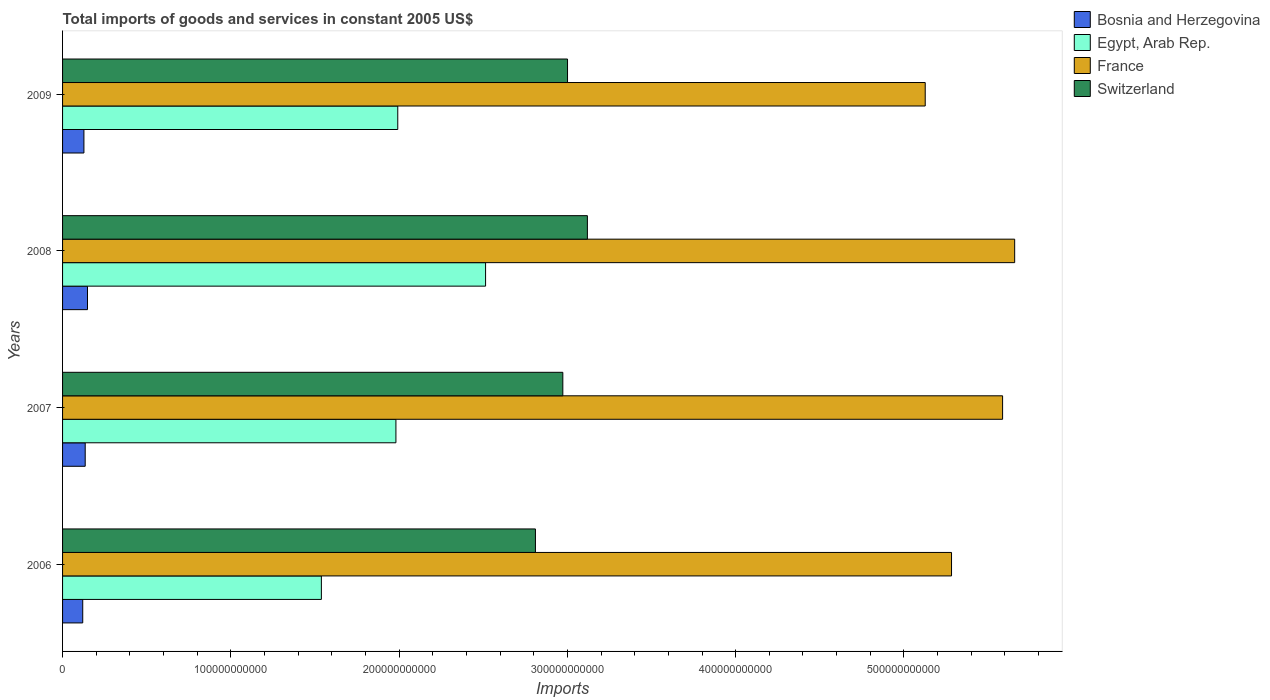How many groups of bars are there?
Offer a terse response. 4. Are the number of bars on each tick of the Y-axis equal?
Offer a very short reply. Yes. How many bars are there on the 2nd tick from the top?
Offer a terse response. 4. What is the label of the 3rd group of bars from the top?
Offer a terse response. 2007. What is the total imports of goods and services in Bosnia and Herzegovina in 2007?
Provide a short and direct response. 1.35e+1. Across all years, what is the maximum total imports of goods and services in France?
Offer a terse response. 5.66e+11. Across all years, what is the minimum total imports of goods and services in Egypt, Arab Rep.?
Give a very brief answer. 1.54e+11. In which year was the total imports of goods and services in Bosnia and Herzegovina maximum?
Provide a short and direct response. 2008. In which year was the total imports of goods and services in Switzerland minimum?
Your answer should be very brief. 2006. What is the total total imports of goods and services in France in the graph?
Keep it short and to the point. 2.17e+12. What is the difference between the total imports of goods and services in Egypt, Arab Rep. in 2006 and that in 2008?
Offer a terse response. -9.76e+1. What is the difference between the total imports of goods and services in Switzerland in 2009 and the total imports of goods and services in France in 2008?
Provide a succinct answer. -2.66e+11. What is the average total imports of goods and services in France per year?
Provide a short and direct response. 5.41e+11. In the year 2008, what is the difference between the total imports of goods and services in Bosnia and Herzegovina and total imports of goods and services in Egypt, Arab Rep.?
Make the answer very short. -2.37e+11. In how many years, is the total imports of goods and services in Egypt, Arab Rep. greater than 560000000000 US$?
Ensure brevity in your answer.  0. What is the ratio of the total imports of goods and services in Switzerland in 2006 to that in 2008?
Keep it short and to the point. 0.9. Is the total imports of goods and services in France in 2006 less than that in 2009?
Your answer should be compact. No. Is the difference between the total imports of goods and services in Bosnia and Herzegovina in 2008 and 2009 greater than the difference between the total imports of goods and services in Egypt, Arab Rep. in 2008 and 2009?
Give a very brief answer. No. What is the difference between the highest and the second highest total imports of goods and services in Egypt, Arab Rep.?
Your answer should be very brief. 5.22e+1. What is the difference between the highest and the lowest total imports of goods and services in France?
Make the answer very short. 5.32e+1. Is the sum of the total imports of goods and services in France in 2006 and 2007 greater than the maximum total imports of goods and services in Switzerland across all years?
Your answer should be very brief. Yes. What does the 2nd bar from the top in 2006 represents?
Your answer should be very brief. France. What does the 2nd bar from the bottom in 2009 represents?
Offer a very short reply. Egypt, Arab Rep. How many years are there in the graph?
Your answer should be compact. 4. What is the difference between two consecutive major ticks on the X-axis?
Offer a terse response. 1.00e+11. Are the values on the major ticks of X-axis written in scientific E-notation?
Provide a short and direct response. No. Does the graph contain any zero values?
Offer a very short reply. No. Where does the legend appear in the graph?
Keep it short and to the point. Top right. How many legend labels are there?
Your response must be concise. 4. How are the legend labels stacked?
Your answer should be compact. Vertical. What is the title of the graph?
Offer a terse response. Total imports of goods and services in constant 2005 US$. Does "Haiti" appear as one of the legend labels in the graph?
Give a very brief answer. No. What is the label or title of the X-axis?
Provide a succinct answer. Imports. What is the Imports of Bosnia and Herzegovina in 2006?
Give a very brief answer. 1.20e+1. What is the Imports in Egypt, Arab Rep. in 2006?
Provide a succinct answer. 1.54e+11. What is the Imports of France in 2006?
Your answer should be very brief. 5.28e+11. What is the Imports of Switzerland in 2006?
Ensure brevity in your answer.  2.81e+11. What is the Imports in Bosnia and Herzegovina in 2007?
Offer a very short reply. 1.35e+1. What is the Imports of Egypt, Arab Rep. in 2007?
Offer a very short reply. 1.98e+11. What is the Imports in France in 2007?
Your response must be concise. 5.59e+11. What is the Imports of Switzerland in 2007?
Offer a terse response. 2.97e+11. What is the Imports in Bosnia and Herzegovina in 2008?
Your answer should be very brief. 1.48e+1. What is the Imports of Egypt, Arab Rep. in 2008?
Provide a short and direct response. 2.51e+11. What is the Imports of France in 2008?
Provide a succinct answer. 5.66e+11. What is the Imports in Switzerland in 2008?
Your response must be concise. 3.12e+11. What is the Imports in Bosnia and Herzegovina in 2009?
Your answer should be very brief. 1.27e+1. What is the Imports in Egypt, Arab Rep. in 2009?
Give a very brief answer. 1.99e+11. What is the Imports of France in 2009?
Your answer should be compact. 5.13e+11. What is the Imports of Switzerland in 2009?
Offer a very short reply. 3.00e+11. Across all years, what is the maximum Imports of Bosnia and Herzegovina?
Offer a very short reply. 1.48e+1. Across all years, what is the maximum Imports in Egypt, Arab Rep.?
Offer a very short reply. 2.51e+11. Across all years, what is the maximum Imports of France?
Keep it short and to the point. 5.66e+11. Across all years, what is the maximum Imports of Switzerland?
Provide a short and direct response. 3.12e+11. Across all years, what is the minimum Imports in Bosnia and Herzegovina?
Your answer should be compact. 1.20e+1. Across all years, what is the minimum Imports in Egypt, Arab Rep.?
Offer a very short reply. 1.54e+11. Across all years, what is the minimum Imports in France?
Offer a very short reply. 5.13e+11. Across all years, what is the minimum Imports of Switzerland?
Your answer should be very brief. 2.81e+11. What is the total Imports in Bosnia and Herzegovina in the graph?
Your response must be concise. 5.29e+1. What is the total Imports of Egypt, Arab Rep. in the graph?
Offer a very short reply. 8.02e+11. What is the total Imports in France in the graph?
Your answer should be very brief. 2.17e+12. What is the total Imports of Switzerland in the graph?
Give a very brief answer. 1.19e+12. What is the difference between the Imports of Bosnia and Herzegovina in 2006 and that in 2007?
Your response must be concise. -1.47e+09. What is the difference between the Imports of Egypt, Arab Rep. in 2006 and that in 2007?
Ensure brevity in your answer.  -4.43e+1. What is the difference between the Imports in France in 2006 and that in 2007?
Provide a succinct answer. -3.04e+1. What is the difference between the Imports of Switzerland in 2006 and that in 2007?
Your answer should be very brief. -1.63e+1. What is the difference between the Imports of Bosnia and Herzegovina in 2006 and that in 2008?
Make the answer very short. -2.83e+09. What is the difference between the Imports of Egypt, Arab Rep. in 2006 and that in 2008?
Your answer should be compact. -9.76e+1. What is the difference between the Imports in France in 2006 and that in 2008?
Make the answer very short. -3.75e+1. What is the difference between the Imports in Switzerland in 2006 and that in 2008?
Offer a very short reply. -3.09e+1. What is the difference between the Imports of Bosnia and Herzegovina in 2006 and that in 2009?
Provide a succinct answer. -7.04e+08. What is the difference between the Imports of Egypt, Arab Rep. in 2006 and that in 2009?
Provide a short and direct response. -4.54e+1. What is the difference between the Imports in France in 2006 and that in 2009?
Your answer should be very brief. 1.56e+1. What is the difference between the Imports in Switzerland in 2006 and that in 2009?
Offer a very short reply. -1.91e+1. What is the difference between the Imports in Bosnia and Herzegovina in 2007 and that in 2008?
Your response must be concise. -1.36e+09. What is the difference between the Imports in Egypt, Arab Rep. in 2007 and that in 2008?
Offer a terse response. -5.33e+1. What is the difference between the Imports of France in 2007 and that in 2008?
Provide a succinct answer. -7.17e+09. What is the difference between the Imports in Switzerland in 2007 and that in 2008?
Ensure brevity in your answer.  -1.46e+1. What is the difference between the Imports of Bosnia and Herzegovina in 2007 and that in 2009?
Your response must be concise. 7.62e+08. What is the difference between the Imports in Egypt, Arab Rep. in 2007 and that in 2009?
Your answer should be very brief. -1.10e+09. What is the difference between the Imports in France in 2007 and that in 2009?
Provide a short and direct response. 4.60e+1. What is the difference between the Imports in Switzerland in 2007 and that in 2009?
Your answer should be very brief. -2.79e+09. What is the difference between the Imports of Bosnia and Herzegovina in 2008 and that in 2009?
Your answer should be very brief. 2.13e+09. What is the difference between the Imports of Egypt, Arab Rep. in 2008 and that in 2009?
Provide a succinct answer. 5.22e+1. What is the difference between the Imports in France in 2008 and that in 2009?
Ensure brevity in your answer.  5.32e+1. What is the difference between the Imports of Switzerland in 2008 and that in 2009?
Offer a terse response. 1.18e+1. What is the difference between the Imports in Bosnia and Herzegovina in 2006 and the Imports in Egypt, Arab Rep. in 2007?
Keep it short and to the point. -1.86e+11. What is the difference between the Imports in Bosnia and Herzegovina in 2006 and the Imports in France in 2007?
Provide a succinct answer. -5.47e+11. What is the difference between the Imports in Bosnia and Herzegovina in 2006 and the Imports in Switzerland in 2007?
Ensure brevity in your answer.  -2.85e+11. What is the difference between the Imports of Egypt, Arab Rep. in 2006 and the Imports of France in 2007?
Your response must be concise. -4.05e+11. What is the difference between the Imports in Egypt, Arab Rep. in 2006 and the Imports in Switzerland in 2007?
Your answer should be very brief. -1.43e+11. What is the difference between the Imports of France in 2006 and the Imports of Switzerland in 2007?
Your answer should be compact. 2.31e+11. What is the difference between the Imports of Bosnia and Herzegovina in 2006 and the Imports of Egypt, Arab Rep. in 2008?
Provide a succinct answer. -2.39e+11. What is the difference between the Imports in Bosnia and Herzegovina in 2006 and the Imports in France in 2008?
Offer a terse response. -5.54e+11. What is the difference between the Imports in Bosnia and Herzegovina in 2006 and the Imports in Switzerland in 2008?
Your response must be concise. -3.00e+11. What is the difference between the Imports of Egypt, Arab Rep. in 2006 and the Imports of France in 2008?
Give a very brief answer. -4.12e+11. What is the difference between the Imports in Egypt, Arab Rep. in 2006 and the Imports in Switzerland in 2008?
Offer a terse response. -1.58e+11. What is the difference between the Imports of France in 2006 and the Imports of Switzerland in 2008?
Ensure brevity in your answer.  2.16e+11. What is the difference between the Imports of Bosnia and Herzegovina in 2006 and the Imports of Egypt, Arab Rep. in 2009?
Give a very brief answer. -1.87e+11. What is the difference between the Imports in Bosnia and Herzegovina in 2006 and the Imports in France in 2009?
Make the answer very short. -5.01e+11. What is the difference between the Imports of Bosnia and Herzegovina in 2006 and the Imports of Switzerland in 2009?
Offer a very short reply. -2.88e+11. What is the difference between the Imports in Egypt, Arab Rep. in 2006 and the Imports in France in 2009?
Make the answer very short. -3.59e+11. What is the difference between the Imports in Egypt, Arab Rep. in 2006 and the Imports in Switzerland in 2009?
Provide a succinct answer. -1.46e+11. What is the difference between the Imports in France in 2006 and the Imports in Switzerland in 2009?
Your answer should be compact. 2.28e+11. What is the difference between the Imports of Bosnia and Herzegovina in 2007 and the Imports of Egypt, Arab Rep. in 2008?
Your answer should be very brief. -2.38e+11. What is the difference between the Imports of Bosnia and Herzegovina in 2007 and the Imports of France in 2008?
Give a very brief answer. -5.52e+11. What is the difference between the Imports of Bosnia and Herzegovina in 2007 and the Imports of Switzerland in 2008?
Provide a succinct answer. -2.98e+11. What is the difference between the Imports in Egypt, Arab Rep. in 2007 and the Imports in France in 2008?
Make the answer very short. -3.68e+11. What is the difference between the Imports of Egypt, Arab Rep. in 2007 and the Imports of Switzerland in 2008?
Provide a short and direct response. -1.14e+11. What is the difference between the Imports of France in 2007 and the Imports of Switzerland in 2008?
Keep it short and to the point. 2.47e+11. What is the difference between the Imports of Bosnia and Herzegovina in 2007 and the Imports of Egypt, Arab Rep. in 2009?
Provide a short and direct response. -1.86e+11. What is the difference between the Imports in Bosnia and Herzegovina in 2007 and the Imports in France in 2009?
Your answer should be very brief. -4.99e+11. What is the difference between the Imports in Bosnia and Herzegovina in 2007 and the Imports in Switzerland in 2009?
Your answer should be compact. -2.87e+11. What is the difference between the Imports of Egypt, Arab Rep. in 2007 and the Imports of France in 2009?
Your answer should be very brief. -3.15e+11. What is the difference between the Imports of Egypt, Arab Rep. in 2007 and the Imports of Switzerland in 2009?
Provide a short and direct response. -1.02e+11. What is the difference between the Imports in France in 2007 and the Imports in Switzerland in 2009?
Provide a short and direct response. 2.59e+11. What is the difference between the Imports of Bosnia and Herzegovina in 2008 and the Imports of Egypt, Arab Rep. in 2009?
Give a very brief answer. -1.84e+11. What is the difference between the Imports of Bosnia and Herzegovina in 2008 and the Imports of France in 2009?
Provide a short and direct response. -4.98e+11. What is the difference between the Imports in Bosnia and Herzegovina in 2008 and the Imports in Switzerland in 2009?
Your answer should be compact. -2.85e+11. What is the difference between the Imports of Egypt, Arab Rep. in 2008 and the Imports of France in 2009?
Provide a succinct answer. -2.61e+11. What is the difference between the Imports of Egypt, Arab Rep. in 2008 and the Imports of Switzerland in 2009?
Make the answer very short. -4.87e+1. What is the difference between the Imports in France in 2008 and the Imports in Switzerland in 2009?
Offer a terse response. 2.66e+11. What is the average Imports of Bosnia and Herzegovina per year?
Your response must be concise. 1.32e+1. What is the average Imports in Egypt, Arab Rep. per year?
Provide a succinct answer. 2.01e+11. What is the average Imports of France per year?
Give a very brief answer. 5.41e+11. What is the average Imports of Switzerland per year?
Offer a very short reply. 2.98e+11. In the year 2006, what is the difference between the Imports in Bosnia and Herzegovina and Imports in Egypt, Arab Rep.?
Offer a very short reply. -1.42e+11. In the year 2006, what is the difference between the Imports of Bosnia and Herzegovina and Imports of France?
Your answer should be compact. -5.16e+11. In the year 2006, what is the difference between the Imports of Bosnia and Herzegovina and Imports of Switzerland?
Your response must be concise. -2.69e+11. In the year 2006, what is the difference between the Imports in Egypt, Arab Rep. and Imports in France?
Make the answer very short. -3.74e+11. In the year 2006, what is the difference between the Imports of Egypt, Arab Rep. and Imports of Switzerland?
Your answer should be compact. -1.27e+11. In the year 2006, what is the difference between the Imports in France and Imports in Switzerland?
Your answer should be compact. 2.47e+11. In the year 2007, what is the difference between the Imports in Bosnia and Herzegovina and Imports in Egypt, Arab Rep.?
Provide a short and direct response. -1.85e+11. In the year 2007, what is the difference between the Imports in Bosnia and Herzegovina and Imports in France?
Give a very brief answer. -5.45e+11. In the year 2007, what is the difference between the Imports of Bosnia and Herzegovina and Imports of Switzerland?
Offer a terse response. -2.84e+11. In the year 2007, what is the difference between the Imports in Egypt, Arab Rep. and Imports in France?
Ensure brevity in your answer.  -3.61e+11. In the year 2007, what is the difference between the Imports of Egypt, Arab Rep. and Imports of Switzerland?
Your response must be concise. -9.92e+1. In the year 2007, what is the difference between the Imports of France and Imports of Switzerland?
Make the answer very short. 2.61e+11. In the year 2008, what is the difference between the Imports in Bosnia and Herzegovina and Imports in Egypt, Arab Rep.?
Your answer should be compact. -2.37e+11. In the year 2008, what is the difference between the Imports of Bosnia and Herzegovina and Imports of France?
Provide a succinct answer. -5.51e+11. In the year 2008, what is the difference between the Imports of Bosnia and Herzegovina and Imports of Switzerland?
Keep it short and to the point. -2.97e+11. In the year 2008, what is the difference between the Imports in Egypt, Arab Rep. and Imports in France?
Give a very brief answer. -3.14e+11. In the year 2008, what is the difference between the Imports of Egypt, Arab Rep. and Imports of Switzerland?
Ensure brevity in your answer.  -6.05e+1. In the year 2008, what is the difference between the Imports of France and Imports of Switzerland?
Offer a terse response. 2.54e+11. In the year 2009, what is the difference between the Imports of Bosnia and Herzegovina and Imports of Egypt, Arab Rep.?
Offer a terse response. -1.87e+11. In the year 2009, what is the difference between the Imports in Bosnia and Herzegovina and Imports in France?
Your answer should be very brief. -5.00e+11. In the year 2009, what is the difference between the Imports of Bosnia and Herzegovina and Imports of Switzerland?
Your answer should be compact. -2.87e+11. In the year 2009, what is the difference between the Imports in Egypt, Arab Rep. and Imports in France?
Keep it short and to the point. -3.13e+11. In the year 2009, what is the difference between the Imports in Egypt, Arab Rep. and Imports in Switzerland?
Ensure brevity in your answer.  -1.01e+11. In the year 2009, what is the difference between the Imports in France and Imports in Switzerland?
Make the answer very short. 2.13e+11. What is the ratio of the Imports of Bosnia and Herzegovina in 2006 to that in 2007?
Your answer should be very brief. 0.89. What is the ratio of the Imports of Egypt, Arab Rep. in 2006 to that in 2007?
Give a very brief answer. 0.78. What is the ratio of the Imports in France in 2006 to that in 2007?
Your answer should be very brief. 0.95. What is the ratio of the Imports of Switzerland in 2006 to that in 2007?
Your answer should be compact. 0.95. What is the ratio of the Imports in Bosnia and Herzegovina in 2006 to that in 2008?
Your answer should be very brief. 0.81. What is the ratio of the Imports in Egypt, Arab Rep. in 2006 to that in 2008?
Keep it short and to the point. 0.61. What is the ratio of the Imports in France in 2006 to that in 2008?
Your answer should be very brief. 0.93. What is the ratio of the Imports of Switzerland in 2006 to that in 2008?
Keep it short and to the point. 0.9. What is the ratio of the Imports of Bosnia and Herzegovina in 2006 to that in 2009?
Ensure brevity in your answer.  0.94. What is the ratio of the Imports of Egypt, Arab Rep. in 2006 to that in 2009?
Your response must be concise. 0.77. What is the ratio of the Imports of France in 2006 to that in 2009?
Keep it short and to the point. 1.03. What is the ratio of the Imports in Switzerland in 2006 to that in 2009?
Offer a very short reply. 0.94. What is the ratio of the Imports in Bosnia and Herzegovina in 2007 to that in 2008?
Offer a terse response. 0.91. What is the ratio of the Imports of Egypt, Arab Rep. in 2007 to that in 2008?
Keep it short and to the point. 0.79. What is the ratio of the Imports in France in 2007 to that in 2008?
Your answer should be very brief. 0.99. What is the ratio of the Imports of Switzerland in 2007 to that in 2008?
Make the answer very short. 0.95. What is the ratio of the Imports in Bosnia and Herzegovina in 2007 to that in 2009?
Give a very brief answer. 1.06. What is the ratio of the Imports of France in 2007 to that in 2009?
Provide a succinct answer. 1.09. What is the ratio of the Imports of Switzerland in 2007 to that in 2009?
Offer a terse response. 0.99. What is the ratio of the Imports of Bosnia and Herzegovina in 2008 to that in 2009?
Ensure brevity in your answer.  1.17. What is the ratio of the Imports of Egypt, Arab Rep. in 2008 to that in 2009?
Make the answer very short. 1.26. What is the ratio of the Imports in France in 2008 to that in 2009?
Offer a very short reply. 1.1. What is the ratio of the Imports in Switzerland in 2008 to that in 2009?
Make the answer very short. 1.04. What is the difference between the highest and the second highest Imports in Bosnia and Herzegovina?
Your response must be concise. 1.36e+09. What is the difference between the highest and the second highest Imports of Egypt, Arab Rep.?
Ensure brevity in your answer.  5.22e+1. What is the difference between the highest and the second highest Imports of France?
Your response must be concise. 7.17e+09. What is the difference between the highest and the second highest Imports in Switzerland?
Ensure brevity in your answer.  1.18e+1. What is the difference between the highest and the lowest Imports of Bosnia and Herzegovina?
Offer a terse response. 2.83e+09. What is the difference between the highest and the lowest Imports in Egypt, Arab Rep.?
Your answer should be very brief. 9.76e+1. What is the difference between the highest and the lowest Imports of France?
Ensure brevity in your answer.  5.32e+1. What is the difference between the highest and the lowest Imports in Switzerland?
Your answer should be very brief. 3.09e+1. 